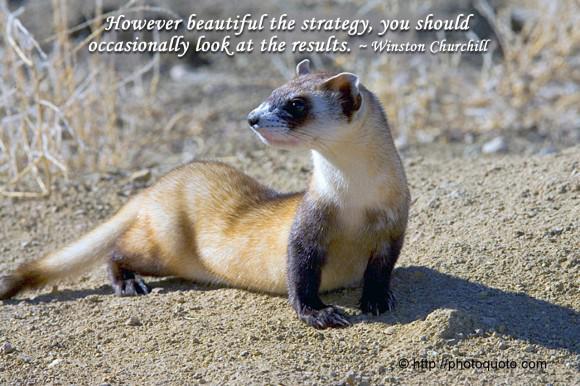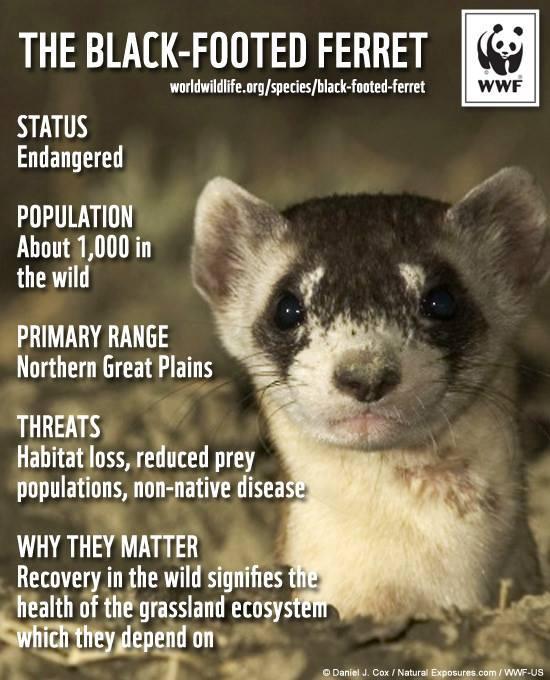The first image is the image on the left, the second image is the image on the right. For the images shown, is this caption "At least one of the images shows a ferret with a head turned away from the animal's sagittal plane." true? Answer yes or no. Yes. 